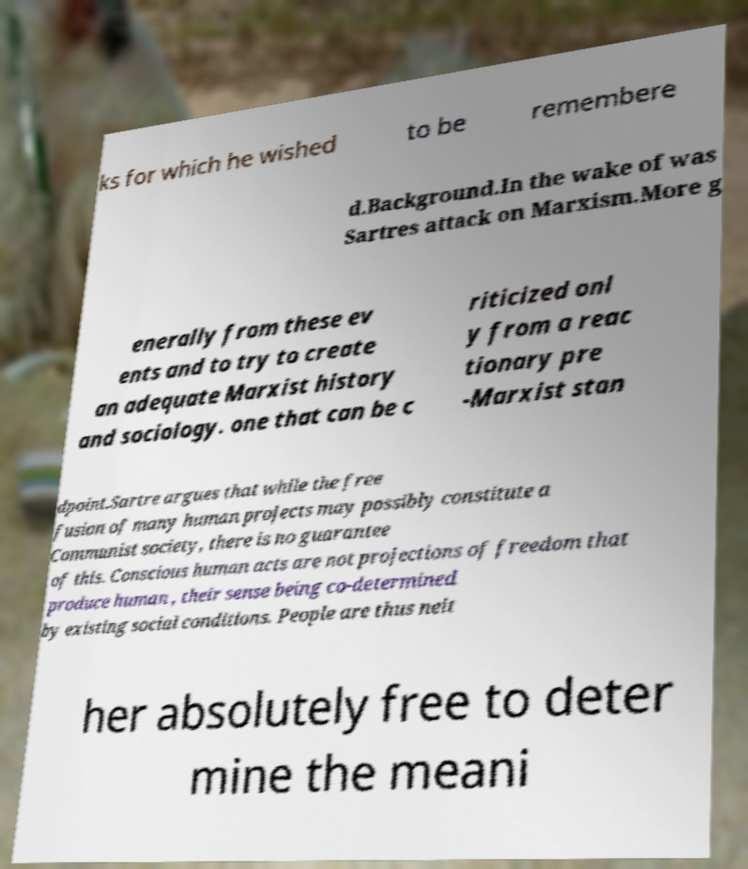There's text embedded in this image that I need extracted. Can you transcribe it verbatim? ks for which he wished to be remembere d.Background.In the wake of was Sartres attack on Marxism.More g enerally from these ev ents and to try to create an adequate Marxist history and sociology. one that can be c riticized onl y from a reac tionary pre -Marxist stan dpoint.Sartre argues that while the free fusion of many human projects may possibly constitute a Communist society, there is no guarantee of this. Conscious human acts are not projections of freedom that produce human , their sense being co-determined by existing social conditions. People are thus neit her absolutely free to deter mine the meani 